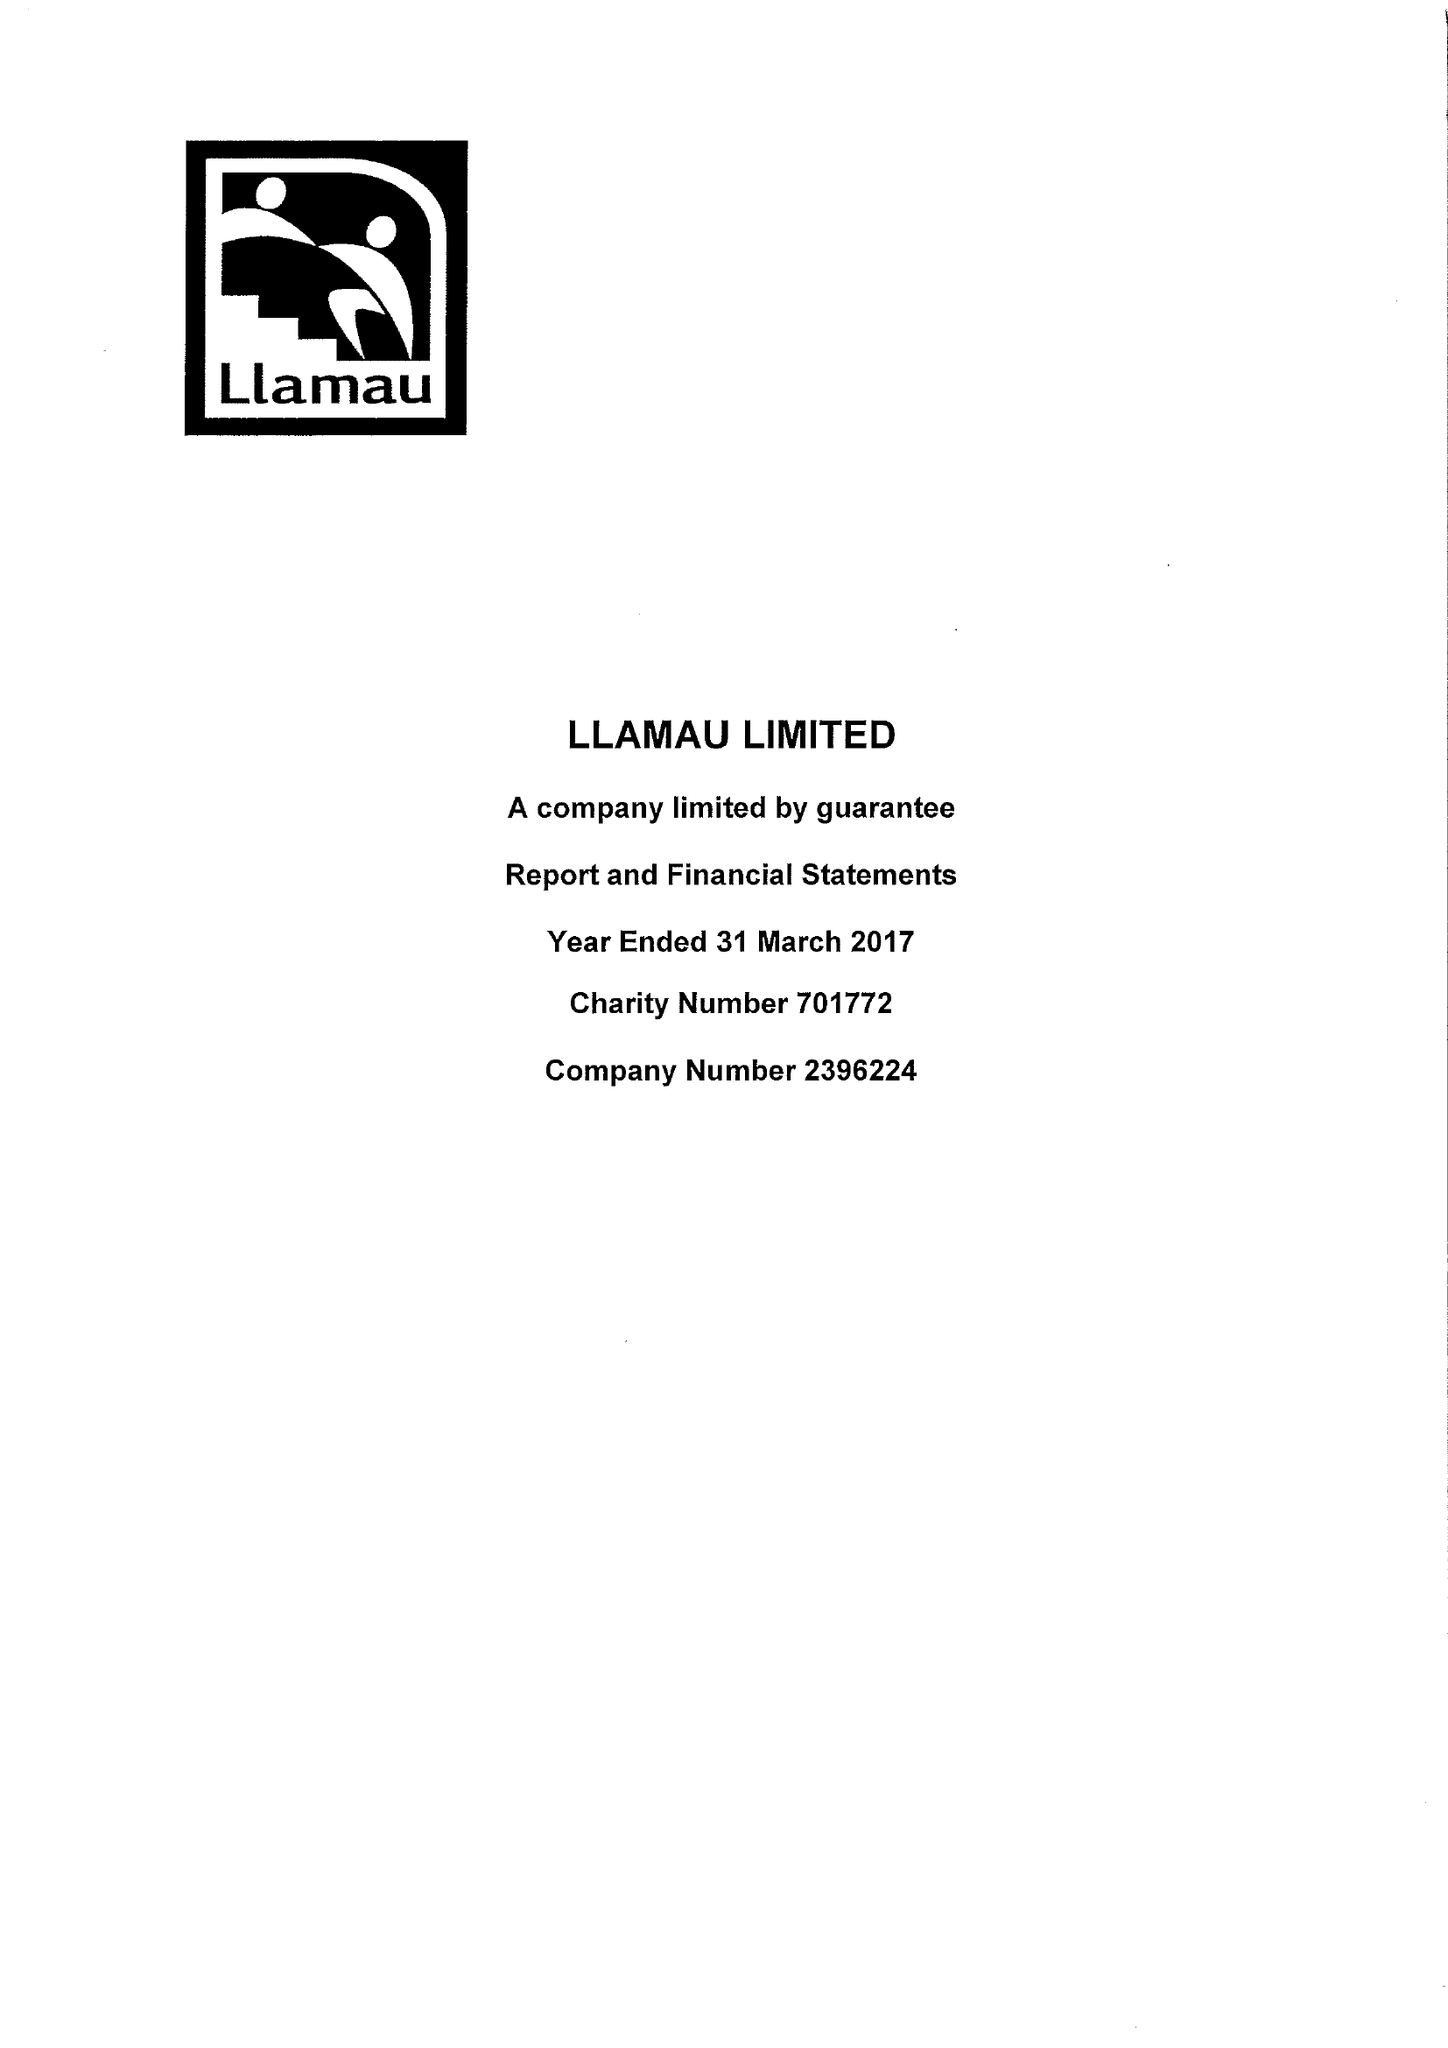What is the value for the charity_name?
Answer the question using a single word or phrase. Llamau Ltd. 